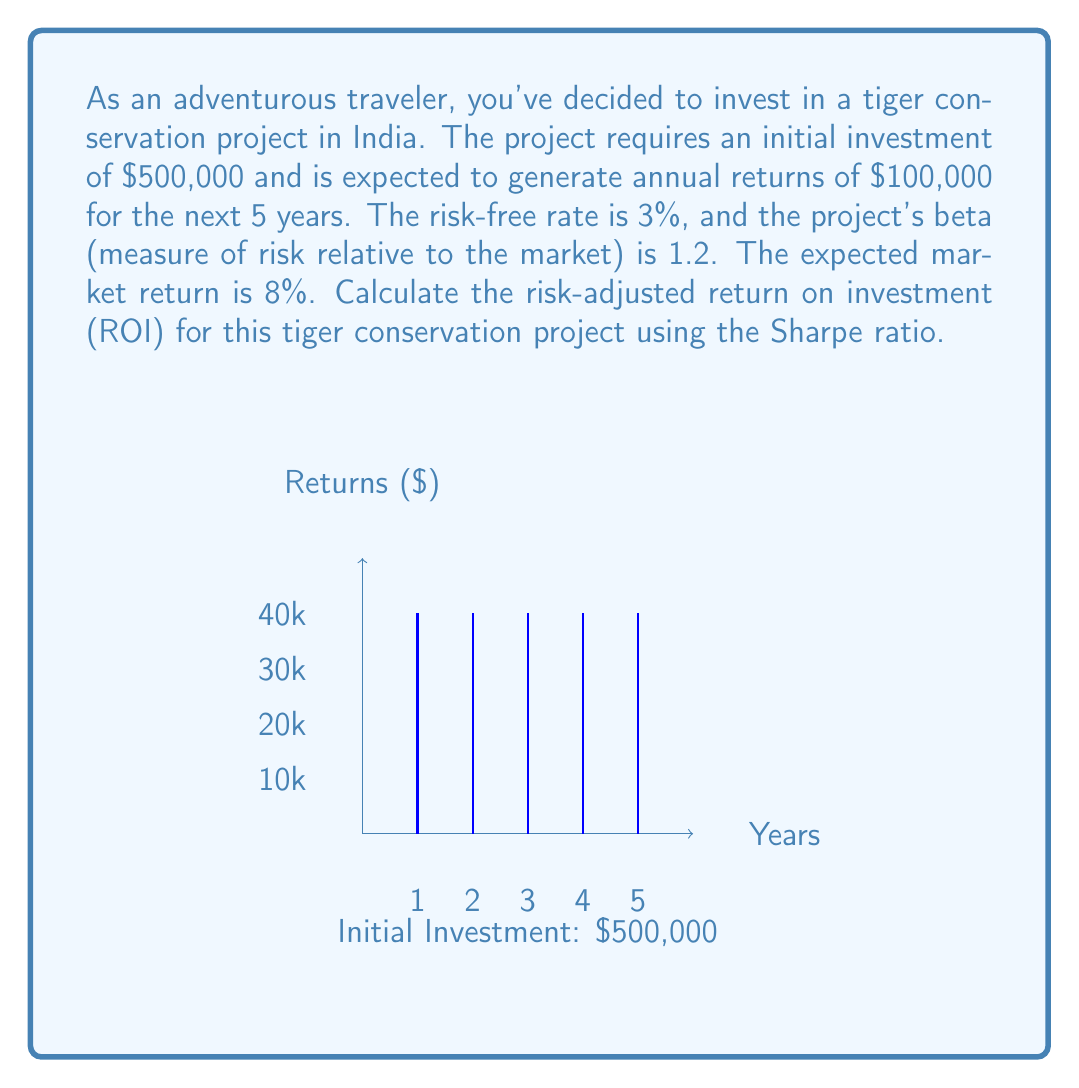Show me your answer to this math problem. To calculate the risk-adjusted ROI using the Sharpe ratio, we need to follow these steps:

1. Calculate the expected return of the project:
   $$E(R_p) = \frac{\text{Total Returns} - \text{Initial Investment}}{\text{Initial Investment}}$$
   $$E(R_p) = \frac{(5 \times \$100,000) - \$500,000}{\$500,000} = 0.20 \text{ or } 20\%$$

2. Calculate the required return using CAPM:
   $$R_p = R_f + \beta(R_m - R_f)$$
   $$R_p = 0.03 + 1.2(0.08 - 0.03) = 0.09 \text{ or } 9\%$$

3. Calculate the excess return:
   $$\text{Excess Return} = E(R_p) - R_p = 0.20 - 0.09 = 0.11 \text{ or } 11\%$$

4. Estimate the standard deviation of the project's returns:
   Assuming the standard deviation is 15% (this is typically estimated based on historical data or similar projects)

5. Calculate the Sharpe ratio:
   $$\text{Sharpe Ratio} = \frac{\text{Excess Return}}{\text{Standard Deviation}}$$
   $$\text{Sharpe Ratio} = \frac{0.11}{0.15} = 0.7333$$

The Sharpe ratio of 0.7333 represents the risk-adjusted return on investment for this tiger conservation project.
Answer: 0.7333 